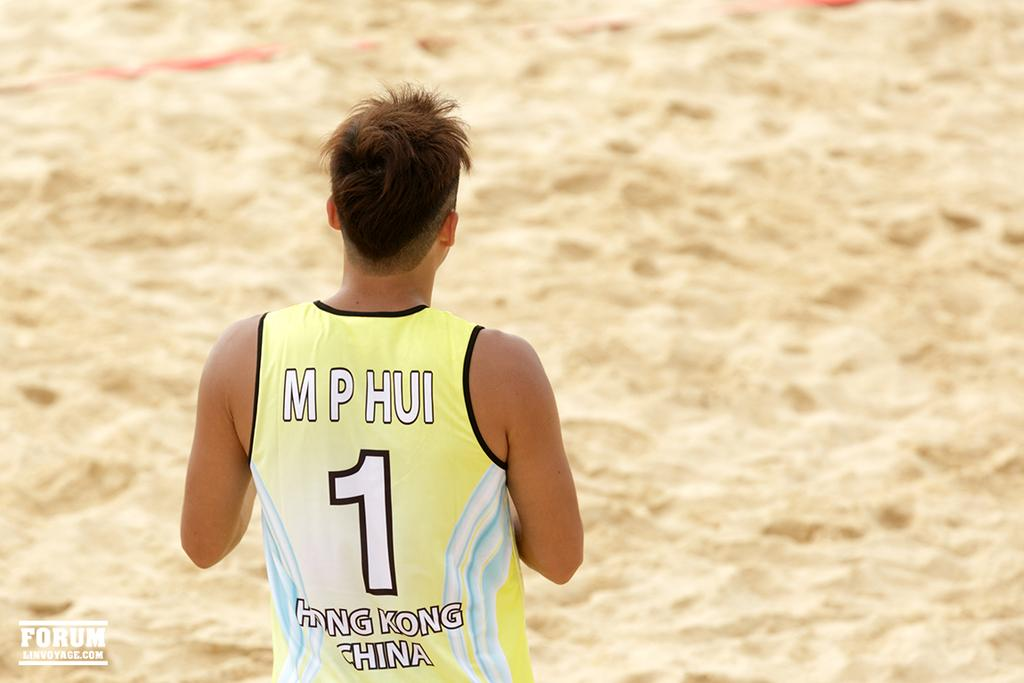<image>
Relay a brief, clear account of the picture shown. a shirt that has the number 1 on it 